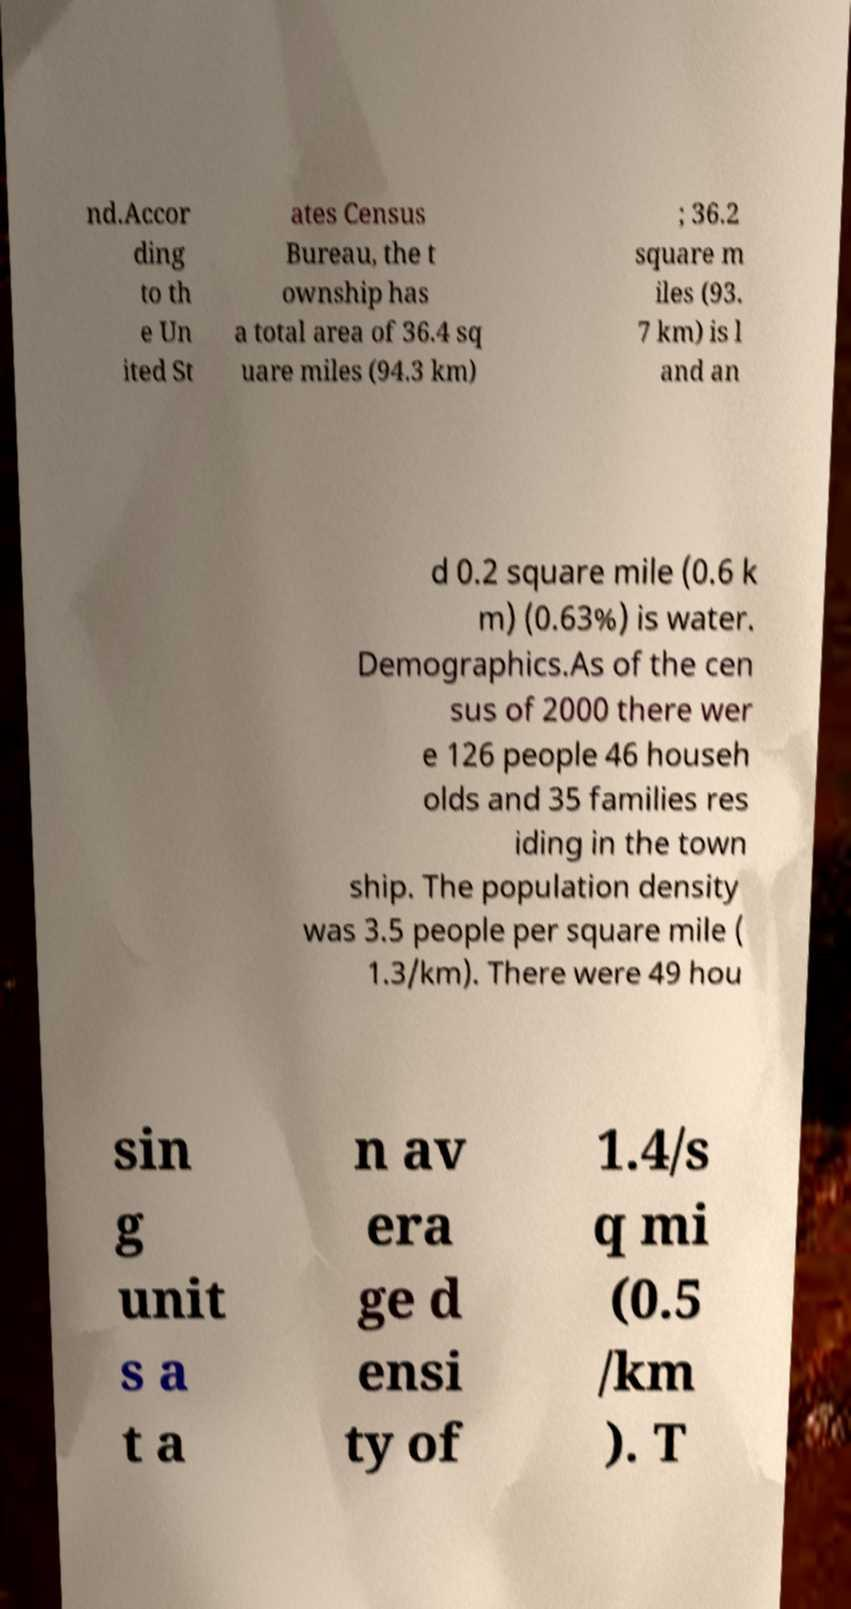Please read and relay the text visible in this image. What does it say? nd.Accor ding to th e Un ited St ates Census Bureau, the t ownship has a total area of 36.4 sq uare miles (94.3 km) ; 36.2 square m iles (93. 7 km) is l and an d 0.2 square mile (0.6 k m) (0.63%) is water. Demographics.As of the cen sus of 2000 there wer e 126 people 46 househ olds and 35 families res iding in the town ship. The population density was 3.5 people per square mile ( 1.3/km). There were 49 hou sin g unit s a t a n av era ge d ensi ty of 1.4/s q mi (0.5 /km ). T 